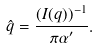<formula> <loc_0><loc_0><loc_500><loc_500>\hat { q } = \frac { ( I ( q ) ) ^ { - 1 } } { \pi \alpha ^ { \prime } } .</formula> 